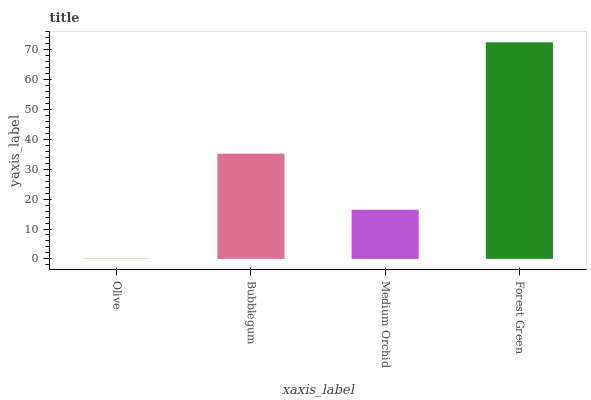Is Olive the minimum?
Answer yes or no. Yes. Is Forest Green the maximum?
Answer yes or no. Yes. Is Bubblegum the minimum?
Answer yes or no. No. Is Bubblegum the maximum?
Answer yes or no. No. Is Bubblegum greater than Olive?
Answer yes or no. Yes. Is Olive less than Bubblegum?
Answer yes or no. Yes. Is Olive greater than Bubblegum?
Answer yes or no. No. Is Bubblegum less than Olive?
Answer yes or no. No. Is Bubblegum the high median?
Answer yes or no. Yes. Is Medium Orchid the low median?
Answer yes or no. Yes. Is Olive the high median?
Answer yes or no. No. Is Olive the low median?
Answer yes or no. No. 